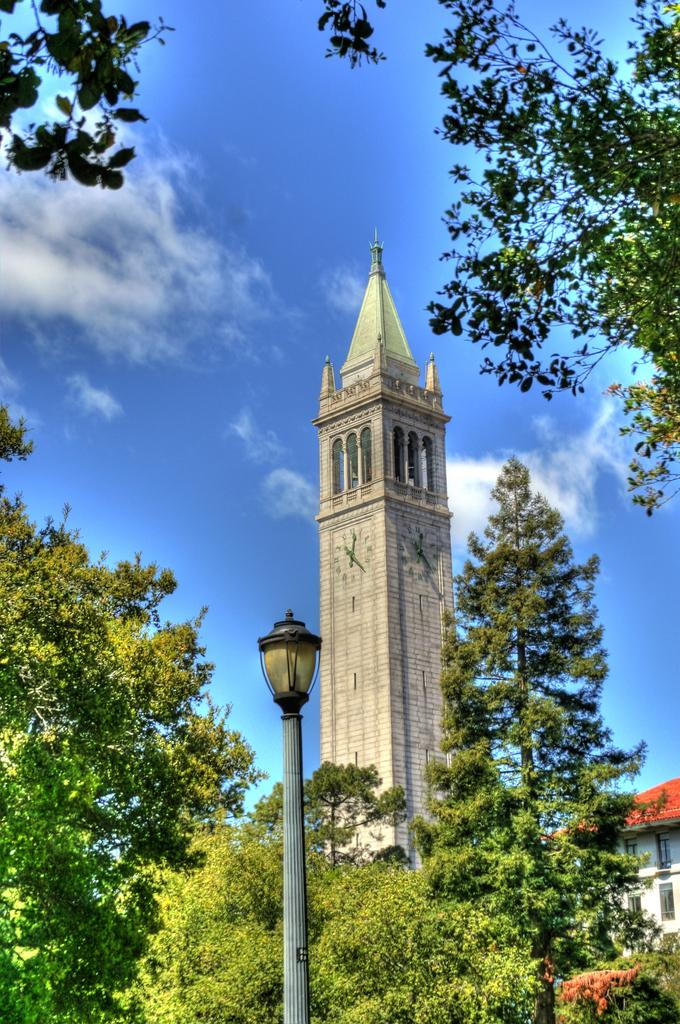What type of vegetation is visible in the image? There are trees in the image. What type of structure can be seen in the background of the image? There is a clock tower in the background of the image. What can be seen in the sky in the image? There are clouds visible in the sky in the image. Can you see a toad hopping near the trees in the image? There is no toad visible in the image. What representative of a political party can be seen in the image? There is no representative of a political party present in the image. 